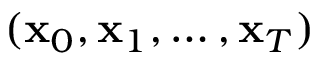Convert formula to latex. <formula><loc_0><loc_0><loc_500><loc_500>( x _ { 0 } , x _ { 1 } , \dots , x _ { T } )</formula> 